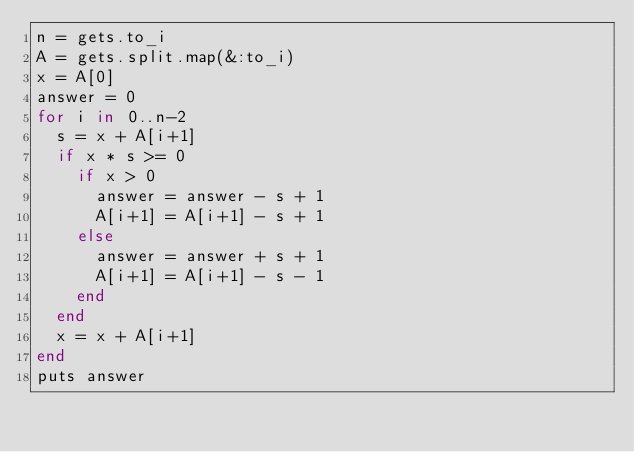<code> <loc_0><loc_0><loc_500><loc_500><_Ruby_>n = gets.to_i
A = gets.split.map(&:to_i)
x = A[0]
answer = 0
for i in 0..n-2
  s = x + A[i+1]
  if x * s >= 0
    if x > 0
      answer = answer - s + 1
      A[i+1] = A[i+1] - s + 1
    else
      answer = answer + s + 1
      A[i+1] = A[i+1] - s - 1  
    end
  end
  x = x + A[i+1]
end
puts answer</code> 